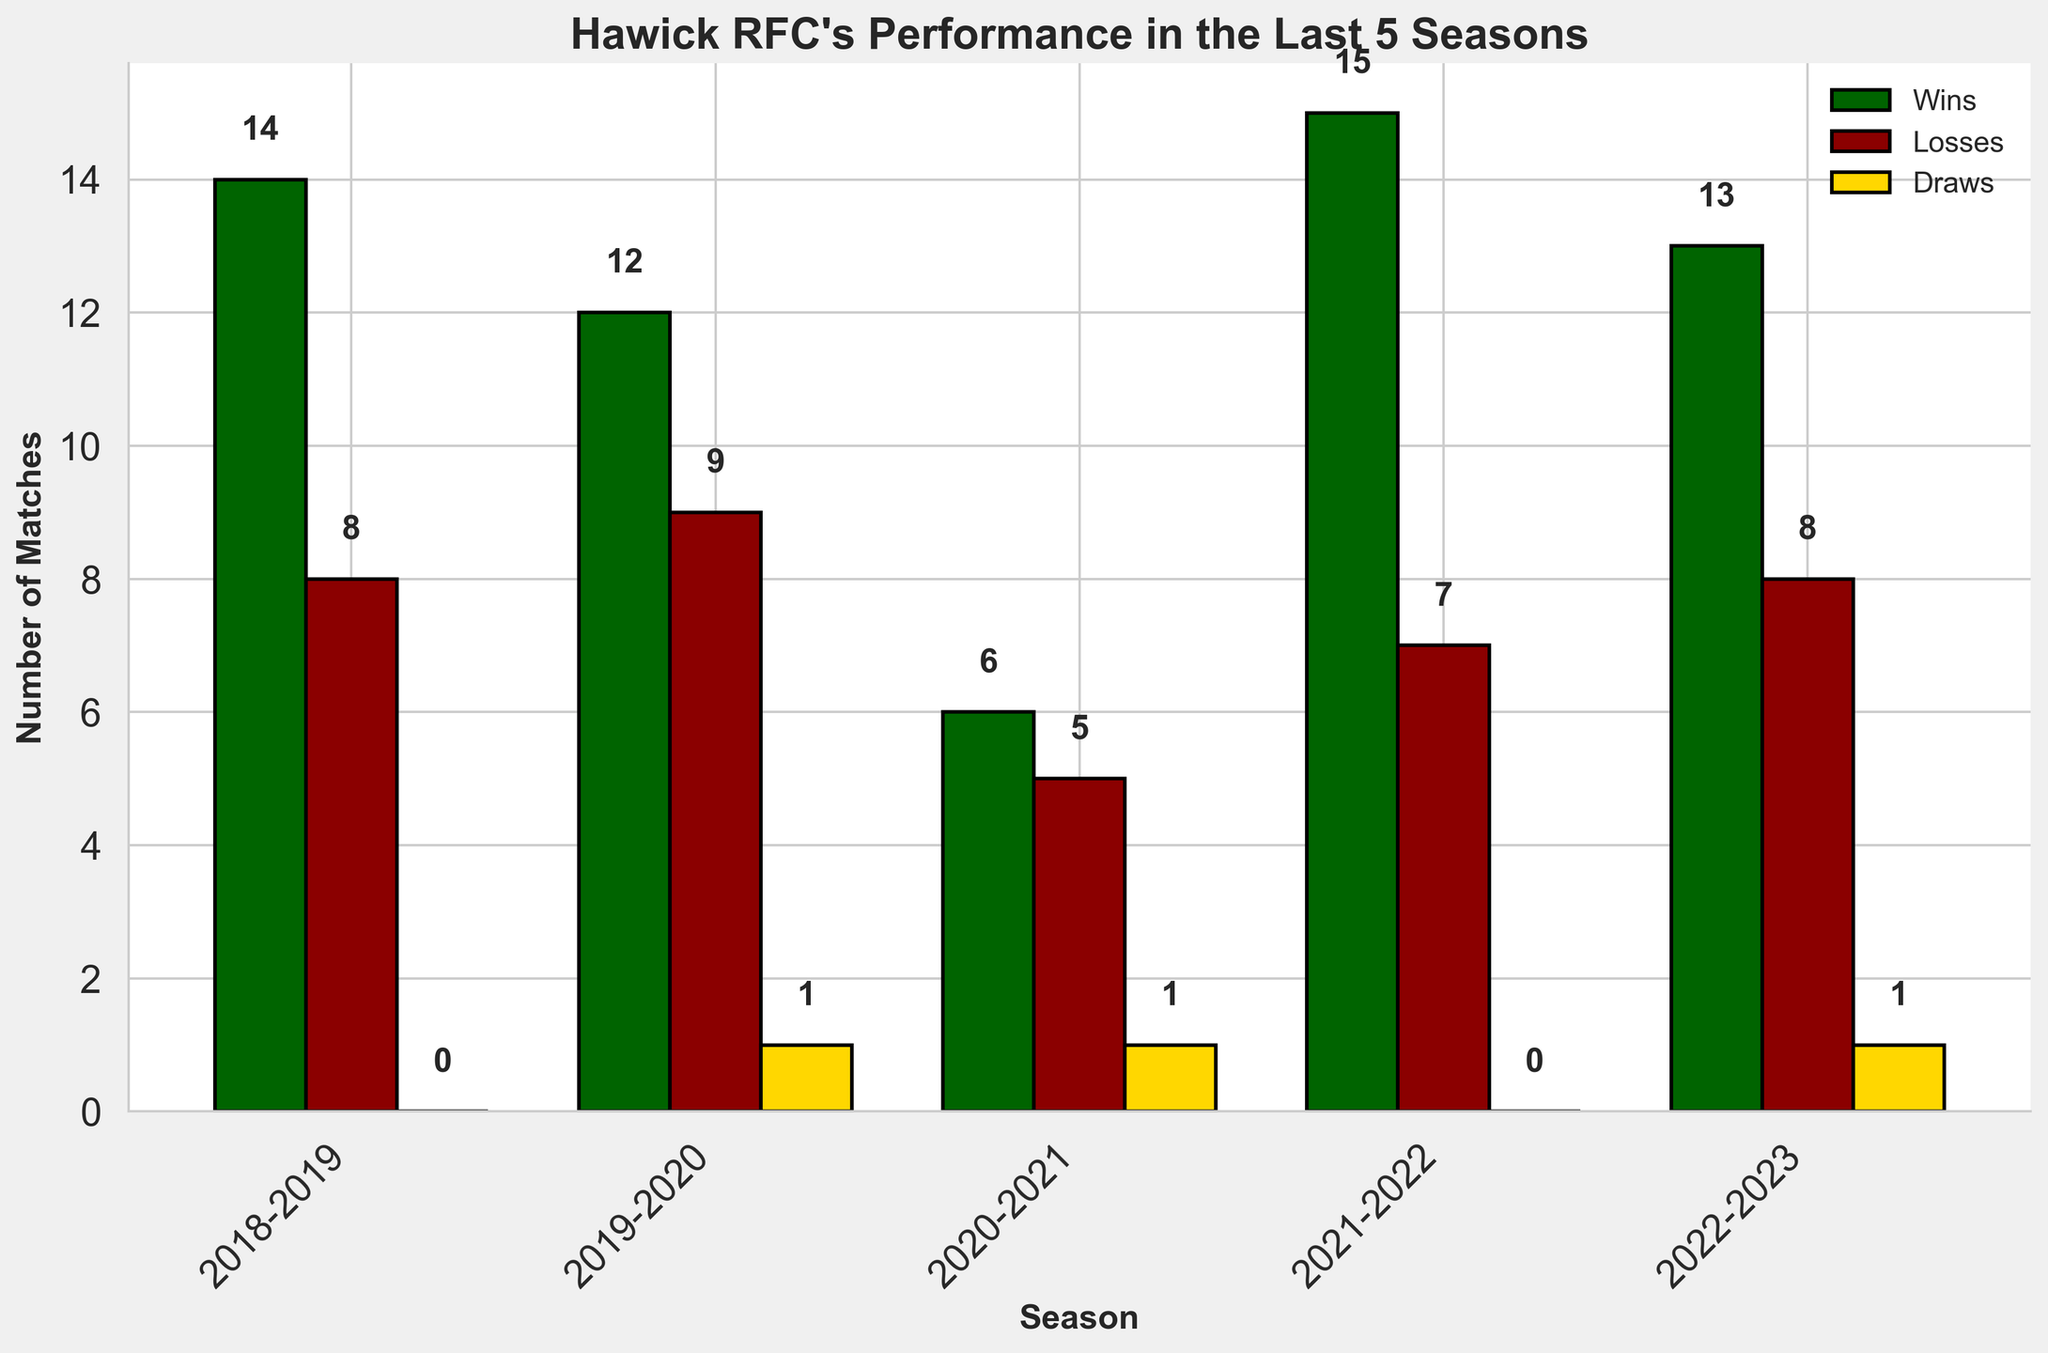How many total matches did Hawick RFC play in the 2020-2021 season? In the 2020-2021 season, the total matches played are the sum of wins, losses, and draws. So, 6 (wins) + 5 (losses) + 1 (draw) = 12 matches.
Answer: 12 Which season did Hawick RFC have the highest number of wins? By comparing the number of wins across all seasons, we see that the 2021-2022 season has the highest with 15 wins.
Answer: 2021-2022 What is the win-loss difference for the 2022-2023 season? The difference between wins and losses for the 2022-2023 season is calculated as 13 (wins) - 8 (losses) = 5.
Answer: 5 How does the number of draws in 2019-2020 compare to 2020-2021? The number of draws in 2019-2020 (1 draw) is the same as in 2020-2021 (1 draw).
Answer: The same Which season had the lowest number of wins? By checking the number of wins in each season, we find that the 2020-2021 season had the lowest with 6 wins.
Answer: 2020-2021 In which season did Hawick RFC have an equal number of wins and losses? By examining the figures, none of the seasons have an equal number of wins and losses; all seasons have differing counts.
Answer: None What is the average number of total matches played per season over the 5 seasons? The total matches per season are added up: 22 (2018-2019) + 22 (2019-2020) + 12 (2020-2021) + 22 (2021-2022) + 22 (2022-2023) = 100. The average is 100 / 5 = 20.
Answer: 20 How many seasons did Hawick RFC have more than 10 wins? By examining each season, we find that Hawick RFC had more than 10 wins in 2018-2019 (14 wins), 2019-2020 (12 wins), 2021-2022 (15 wins), and 2022-2023 (13 wins), totaling 4 seasons.
Answer: 4 Compare the performance trend in wins from the 2018-2019 season to the 2022-2023 season. The trend can be described by checking each season's wins consecutively: 14 (2018-2019), 12 (2019-2020), 6 (2020-2021), 15 (2021-2022), 13 (2022-2023). The wins first decreased to 6 in 2020-2021, then increased to peak at 15 in 2021-2022, and slightly decreased to 13 in 2022-2023.
Answer: Decreasing initially, then increasing, slight decrease in the last season 